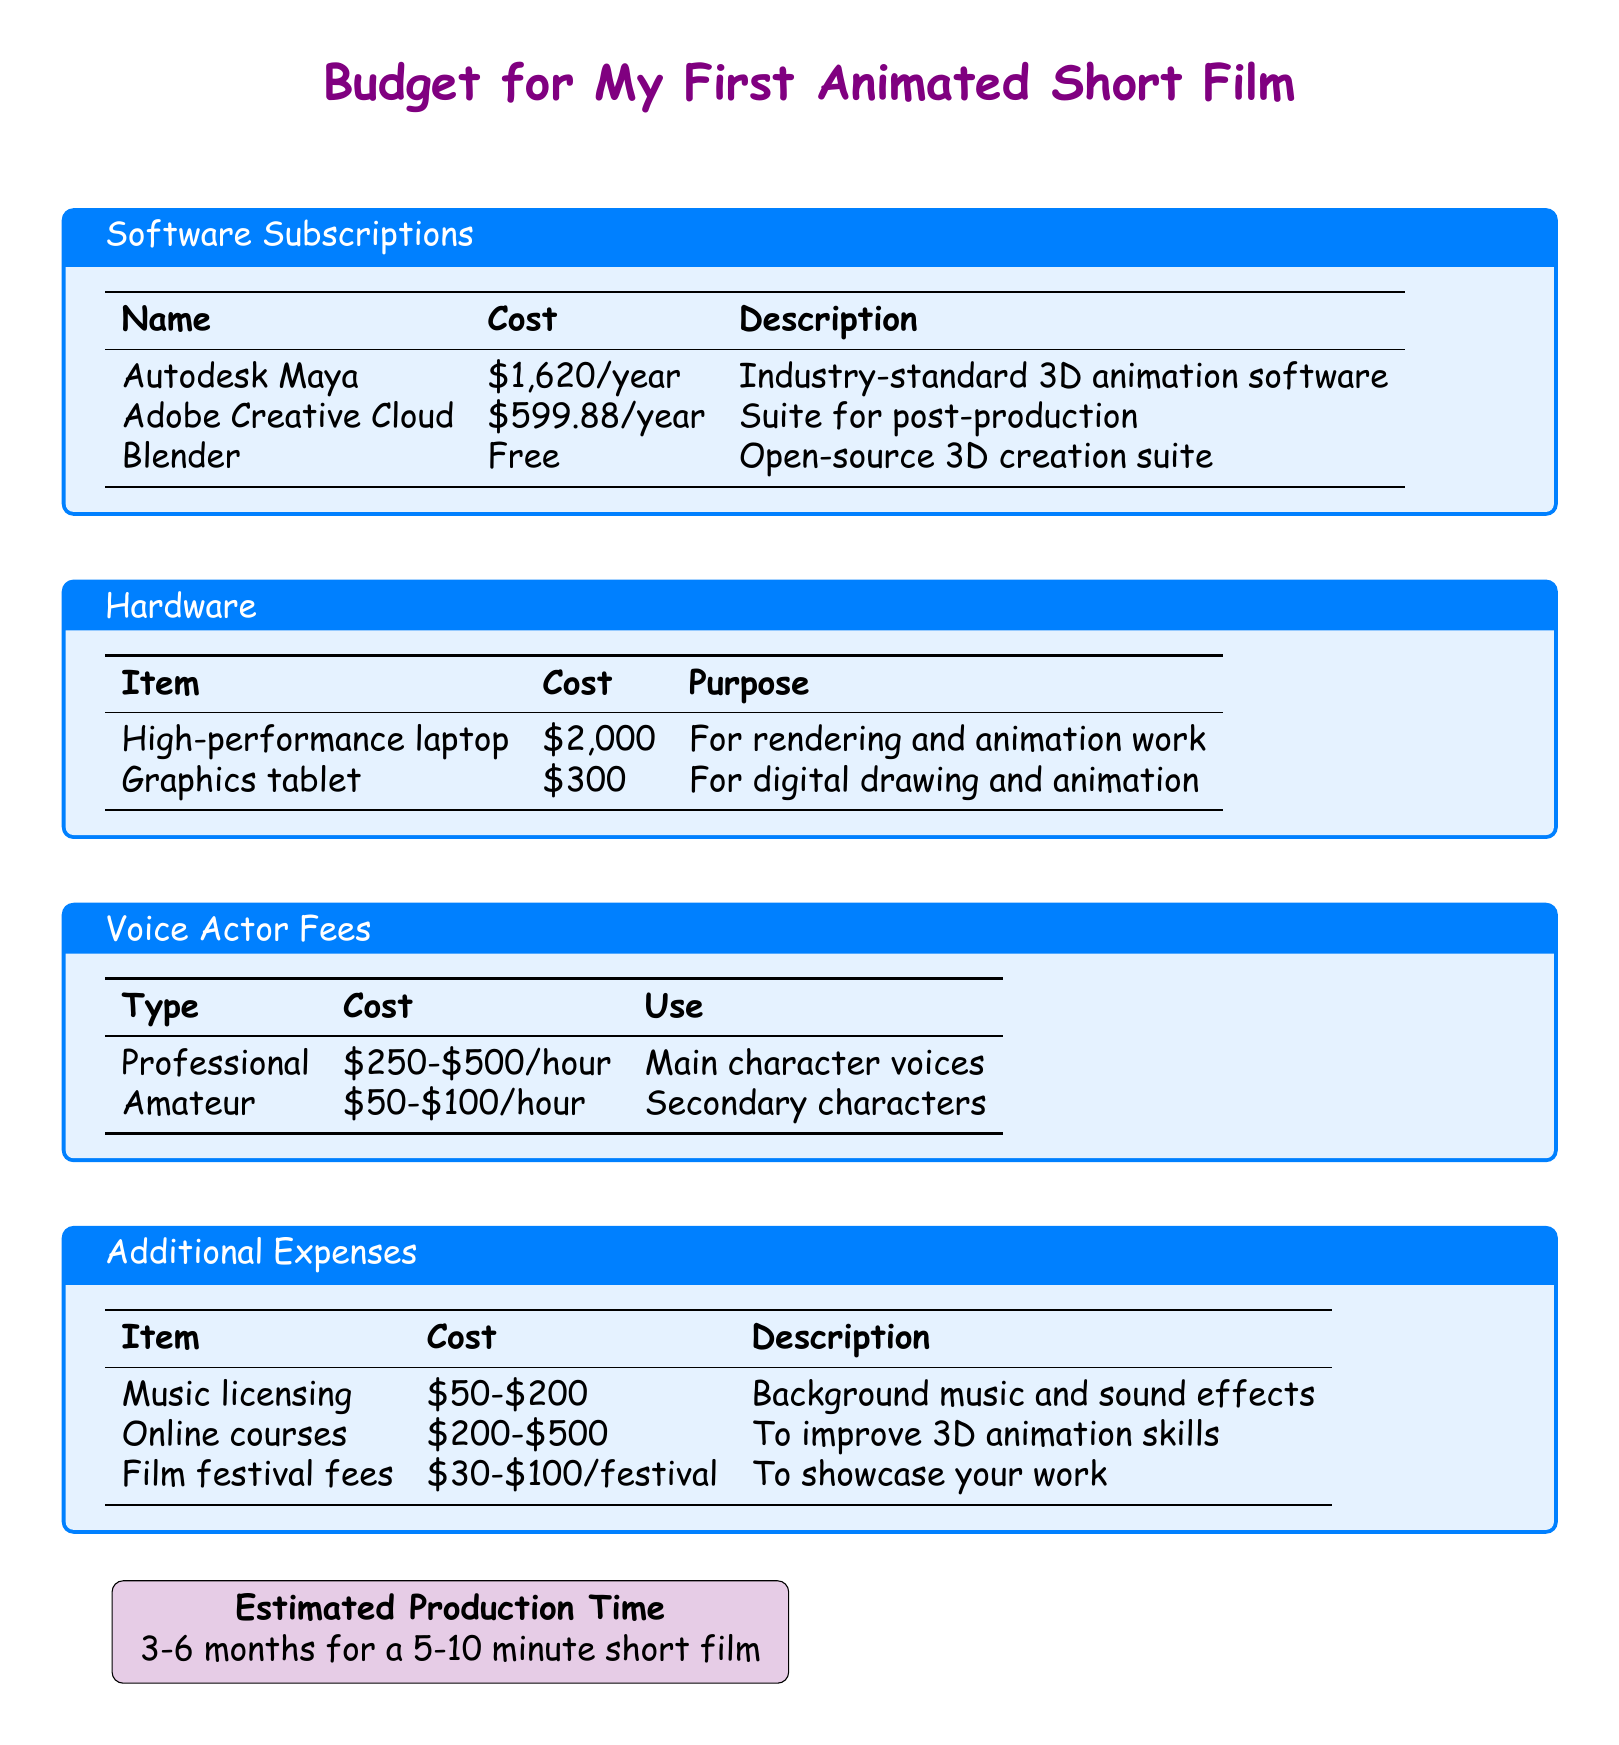What is the cost of Autodesk Maya? The cost of Autodesk Maya is listed in the software subscriptions section of the document.
Answer: $1,620/year What is the purpose of a graphics tablet? The purpose of a graphics tablet is specified under the hardware section of the document.
Answer: For digital drawing and animation What is the range for professional voice actor fees? The range is mentioned in the voice actor fees section and gives the cost for hiring a professional voice actor.
Answer: $250-$500/hour How much does music licensing cost? The cost of music licensing is detailed in the additional expenses section of the document.
Answer: $50-$200 What is the estimated production time for the short film? The estimated production time is provided in the final section of the document.
Answer: 3-6 months for a 5-10 minute short film Which software is free to use? The document lists all software subscriptions; one of them is explicitly noted as free.
Answer: Blender What is the cost for online courses to improve animation skills? The cost for online courses is outlined in the additional expenses section of the document.
Answer: $200-$500 What type of hardware is recommended for rendering and animation work? The type of hardware is mentioned under the hardware section.
Answer: High-performance laptop What is the cost range for amateur voice actors? The cost range for amateur voice actors is indicated in the voice actor fees section of the document.
Answer: $50-$100/hour 